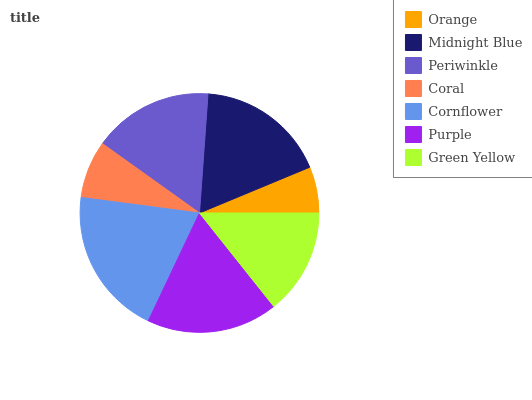Is Orange the minimum?
Answer yes or no. Yes. Is Cornflower the maximum?
Answer yes or no. Yes. Is Midnight Blue the minimum?
Answer yes or no. No. Is Midnight Blue the maximum?
Answer yes or no. No. Is Midnight Blue greater than Orange?
Answer yes or no. Yes. Is Orange less than Midnight Blue?
Answer yes or no. Yes. Is Orange greater than Midnight Blue?
Answer yes or no. No. Is Midnight Blue less than Orange?
Answer yes or no. No. Is Periwinkle the high median?
Answer yes or no. Yes. Is Periwinkle the low median?
Answer yes or no. Yes. Is Purple the high median?
Answer yes or no. No. Is Coral the low median?
Answer yes or no. No. 